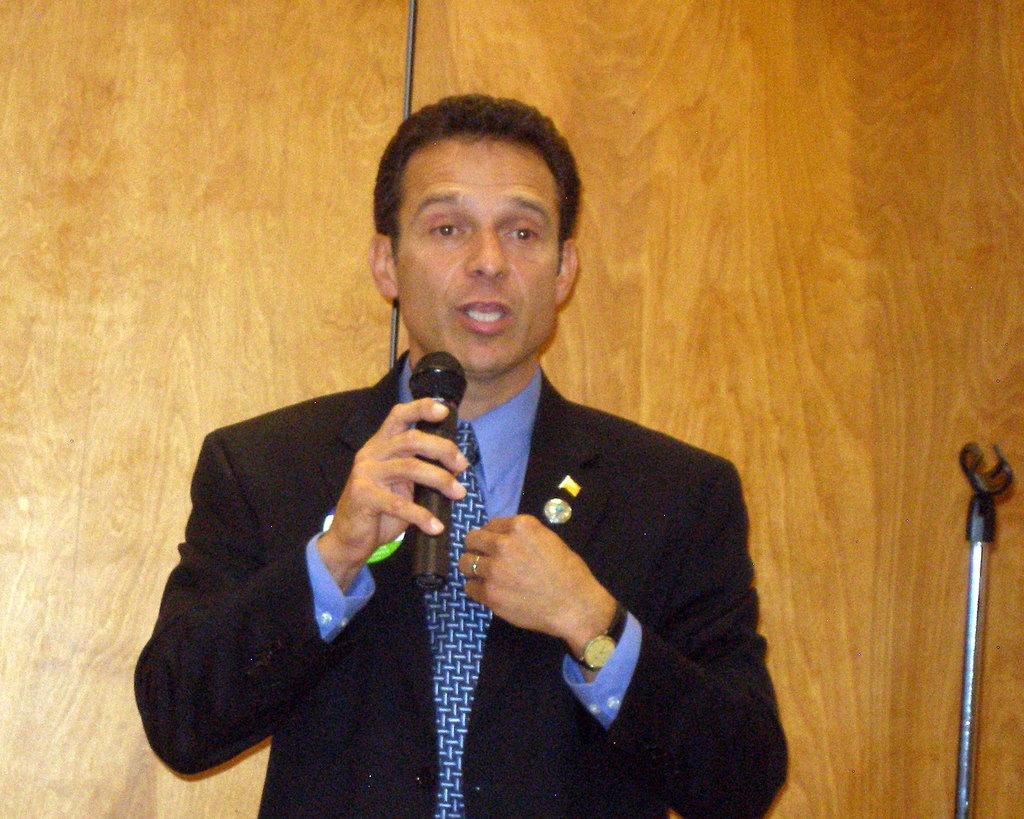In one or two sentences, can you explain what this image depicts? In this picture we can see a man talking on the mic, he wore blazer, tie, watch and some badge to his blazer. In the background we can see wall, wire and a stand for holding something. 